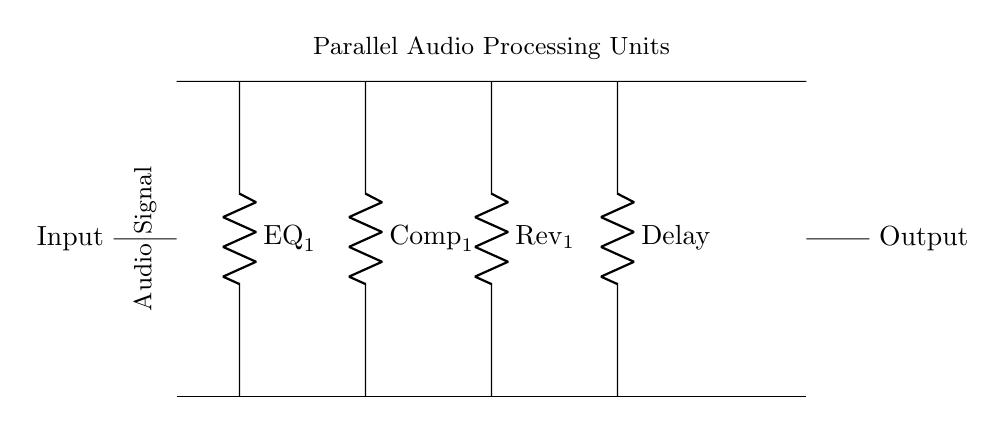What type of circuit is illustrated? The circuit is a parallel circuit as it connects multiple audio processing units simultaneously, allowing each to operate independently while receiving the same input signal.
Answer: Parallel How many audio processing units are in the circuit? There are four audio processing units present in the circuit as indicated by the labels for EQ, Compressor, Reverb, and Delay.
Answer: Four What is the function of the 'Input' node? The 'Input' node serves as the entry point for the audio signal into the circuit. It initiates the flow of signal to the connected processing units.
Answer: Entry point What does the 'Output' node represent? The 'Output' node signifies where the processed audio signal exits the circuit after passing through the various processing units.
Answer: Processed audio exit Which unit is connected directly to the EQ? The Compressor is directly connected to the EQ as both are parallel to each other along the same bus line.
Answer: Compressor What is the effect of a parallel configuration in this circuit? In a parallel configuration, the processing units can be altered independently without affecting each other, allowing for simultaneous audio effects.
Answer: Independent processing What does a label like 'EQ_1' signify in this circuit? The label 'EQ_1' indicates that this component is an equalizer designed for audio processing, specifically to adjust the tonal qualities of the audio signal.
Answer: Equalizer design 